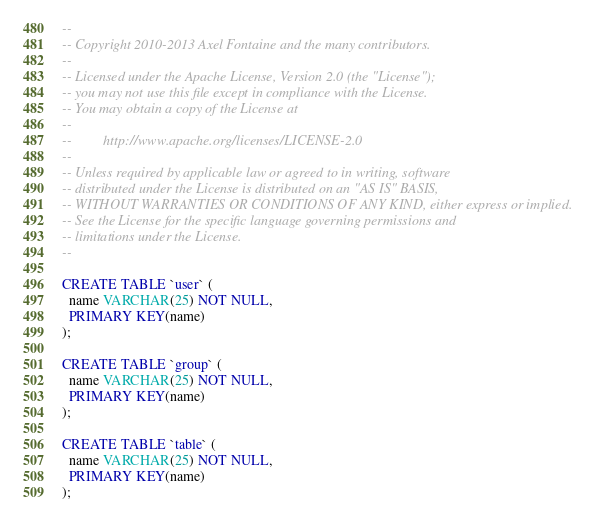<code> <loc_0><loc_0><loc_500><loc_500><_SQL_>--
-- Copyright 2010-2013 Axel Fontaine and the many contributors.
--
-- Licensed under the Apache License, Version 2.0 (the "License");
-- you may not use this file except in compliance with the License.
-- You may obtain a copy of the License at
--
--         http://www.apache.org/licenses/LICENSE-2.0
--
-- Unless required by applicable law or agreed to in writing, software
-- distributed under the License is distributed on an "AS IS" BASIS,
-- WITHOUT WARRANTIES OR CONDITIONS OF ANY KIND, either express or implied.
-- See the License for the specific language governing permissions and
-- limitations under the License.
--

CREATE TABLE `user` (
  name VARCHAR(25) NOT NULL,
  PRIMARY KEY(name)
);

CREATE TABLE `group` (
  name VARCHAR(25) NOT NULL,
  PRIMARY KEY(name)
);

CREATE TABLE `table` (
  name VARCHAR(25) NOT NULL,
  PRIMARY KEY(name)
);</code> 